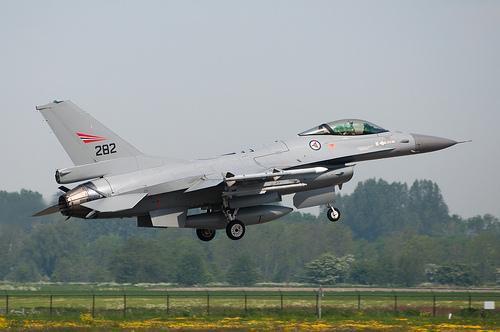How many planes?
Give a very brief answer. 1. 